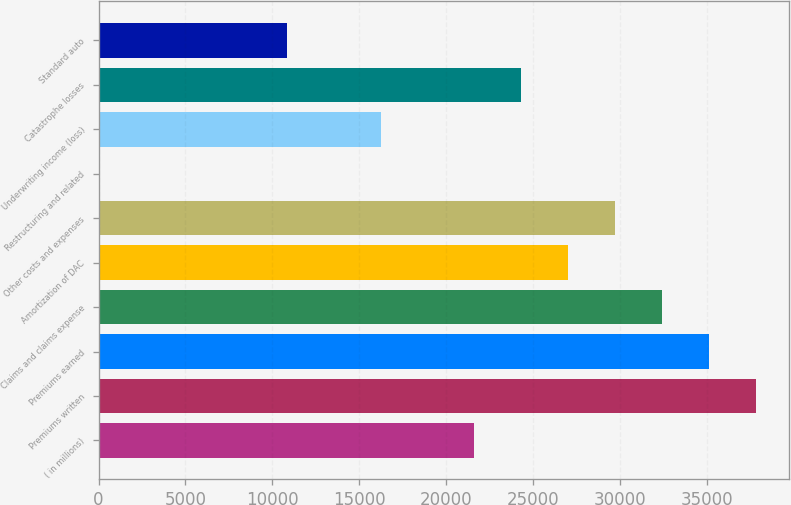<chart> <loc_0><loc_0><loc_500><loc_500><bar_chart><fcel>( in millions)<fcel>Premiums written<fcel>Premiums earned<fcel>Claims and claims expense<fcel>Amortization of DAC<fcel>Other costs and expenses<fcel>Restructuring and related<fcel>Underwriting income (loss)<fcel>Catastrophe losses<fcel>Standard auto<nl><fcel>21627.6<fcel>37822.8<fcel>35123.6<fcel>32424.4<fcel>27026<fcel>29725.2<fcel>34<fcel>16229.2<fcel>24326.8<fcel>10830.8<nl></chart> 